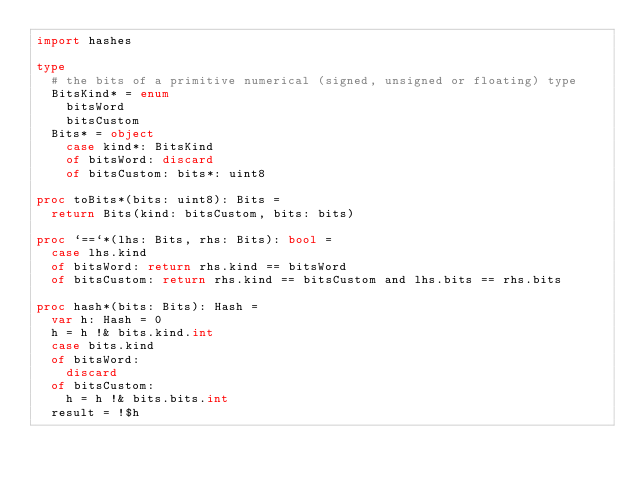Convert code to text. <code><loc_0><loc_0><loc_500><loc_500><_Nim_>import hashes

type
  # the bits of a primitive numerical (signed, unsigned or floating) type
  BitsKind* = enum
    bitsWord
    bitsCustom
  Bits* = object
    case kind*: BitsKind
    of bitsWord: discard
    of bitsCustom: bits*: uint8

proc toBits*(bits: uint8): Bits =
  return Bits(kind: bitsCustom, bits: bits)

proc `==`*(lhs: Bits, rhs: Bits): bool =
  case lhs.kind
  of bitsWord: return rhs.kind == bitsWord
  of bitsCustom: return rhs.kind == bitsCustom and lhs.bits == rhs.bits

proc hash*(bits: Bits): Hash =
  var h: Hash = 0
  h = h !& bits.kind.int
  case bits.kind
  of bitsWord:
    discard
  of bitsCustom:
    h = h !& bits.bits.int
  result = !$h
</code> 